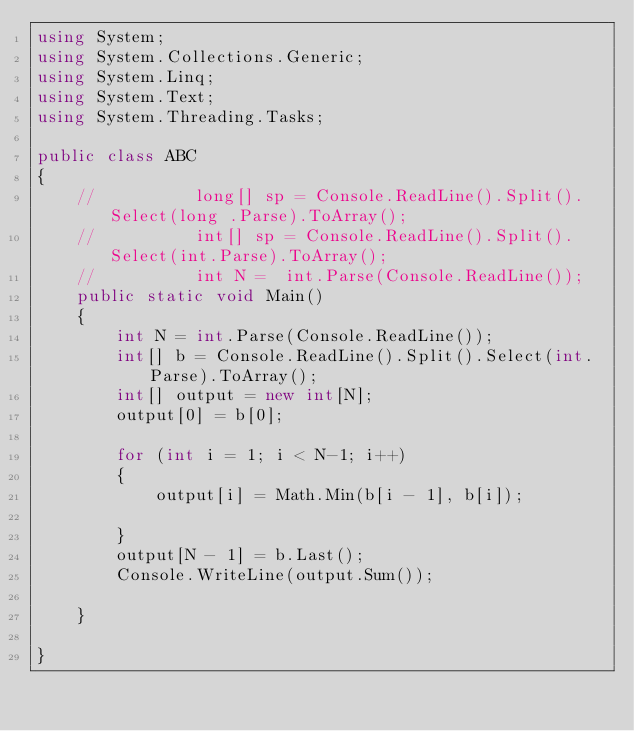<code> <loc_0><loc_0><loc_500><loc_500><_C#_>using System;
using System.Collections.Generic;
using System.Linq;
using System.Text;
using System.Threading.Tasks;

public class ABC
{
    //          long[] sp = Console.ReadLine().Split().Select(long .Parse).ToArray();
    //          int[] sp = Console.ReadLine().Split().Select(int.Parse).ToArray();
    //          int N =  int.Parse(Console.ReadLine());
    public static void Main()
    {
        int N = int.Parse(Console.ReadLine());
        int[] b = Console.ReadLine().Split().Select(int.Parse).ToArray();
        int[] output = new int[N];
        output[0] = b[0];

        for (int i = 1; i < N-1; i++)
        {
            output[i] = Math.Min(b[i - 1], b[i]);

        }
        output[N - 1] = b.Last();
        Console.WriteLine(output.Sum());

    }

}</code> 